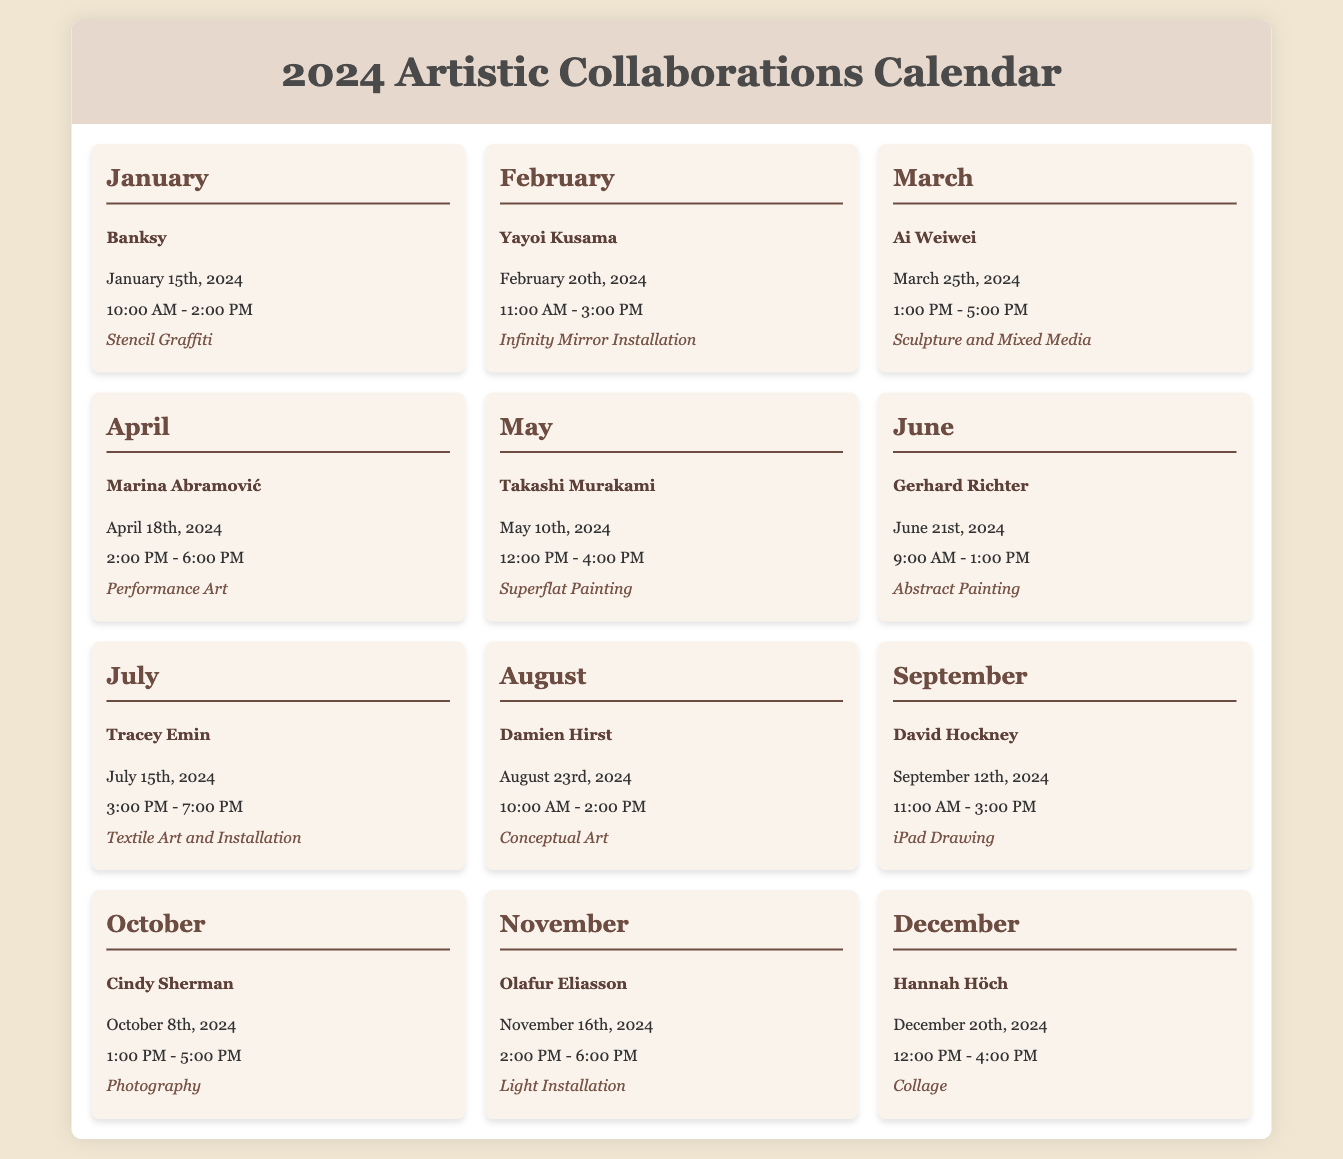What is the date of the collaboration with Banksy? The document states that the collaboration with Banksy is on January 15th, 2024.
Answer: January 15th, 2024 What medium is used in the collaboration with Yayoi Kusama? The document specifies that the medium used with Yayoi Kusama is an Infinity Mirror Installation.
Answer: Infinity Mirror Installation Who is collaborating in March? According to the document, Ai Weiwei is the artist collaborating in March.
Answer: Ai Weiwei What time does the collaboration with Marina Abramović start? The calendar indicates that the collaboration with Marina Abramović starts at 2:00 PM.
Answer: 2:00 PM How many hours is the collaboration with Takashi Murakami? The document shows that the collaboration with Takashi Murakami lasts for 4 hours, from 12:00 PM to 4:00 PM.
Answer: 4 hours Which artist has a collaboration scheduled in August? The calendar lists Damien Hirst as the artist with a collaboration scheduled in August.
Answer: Damien Hirst What is the total number of artistic collaborations listed in the calendar? The document contains 12 collaborations for each month of the year.
Answer: 12 What medium does David Hockney use for his collaboration? The document states that David Hockney uses iPad Drawing for his collaboration.
Answer: iPad Drawing What is the collaboration time range for Olafur Eliasson in November? The calendar specifies that Olafur Eliasson's collaboration time range is from 2:00 PM to 6:00 PM.
Answer: 2:00 PM - 6:00 PM 